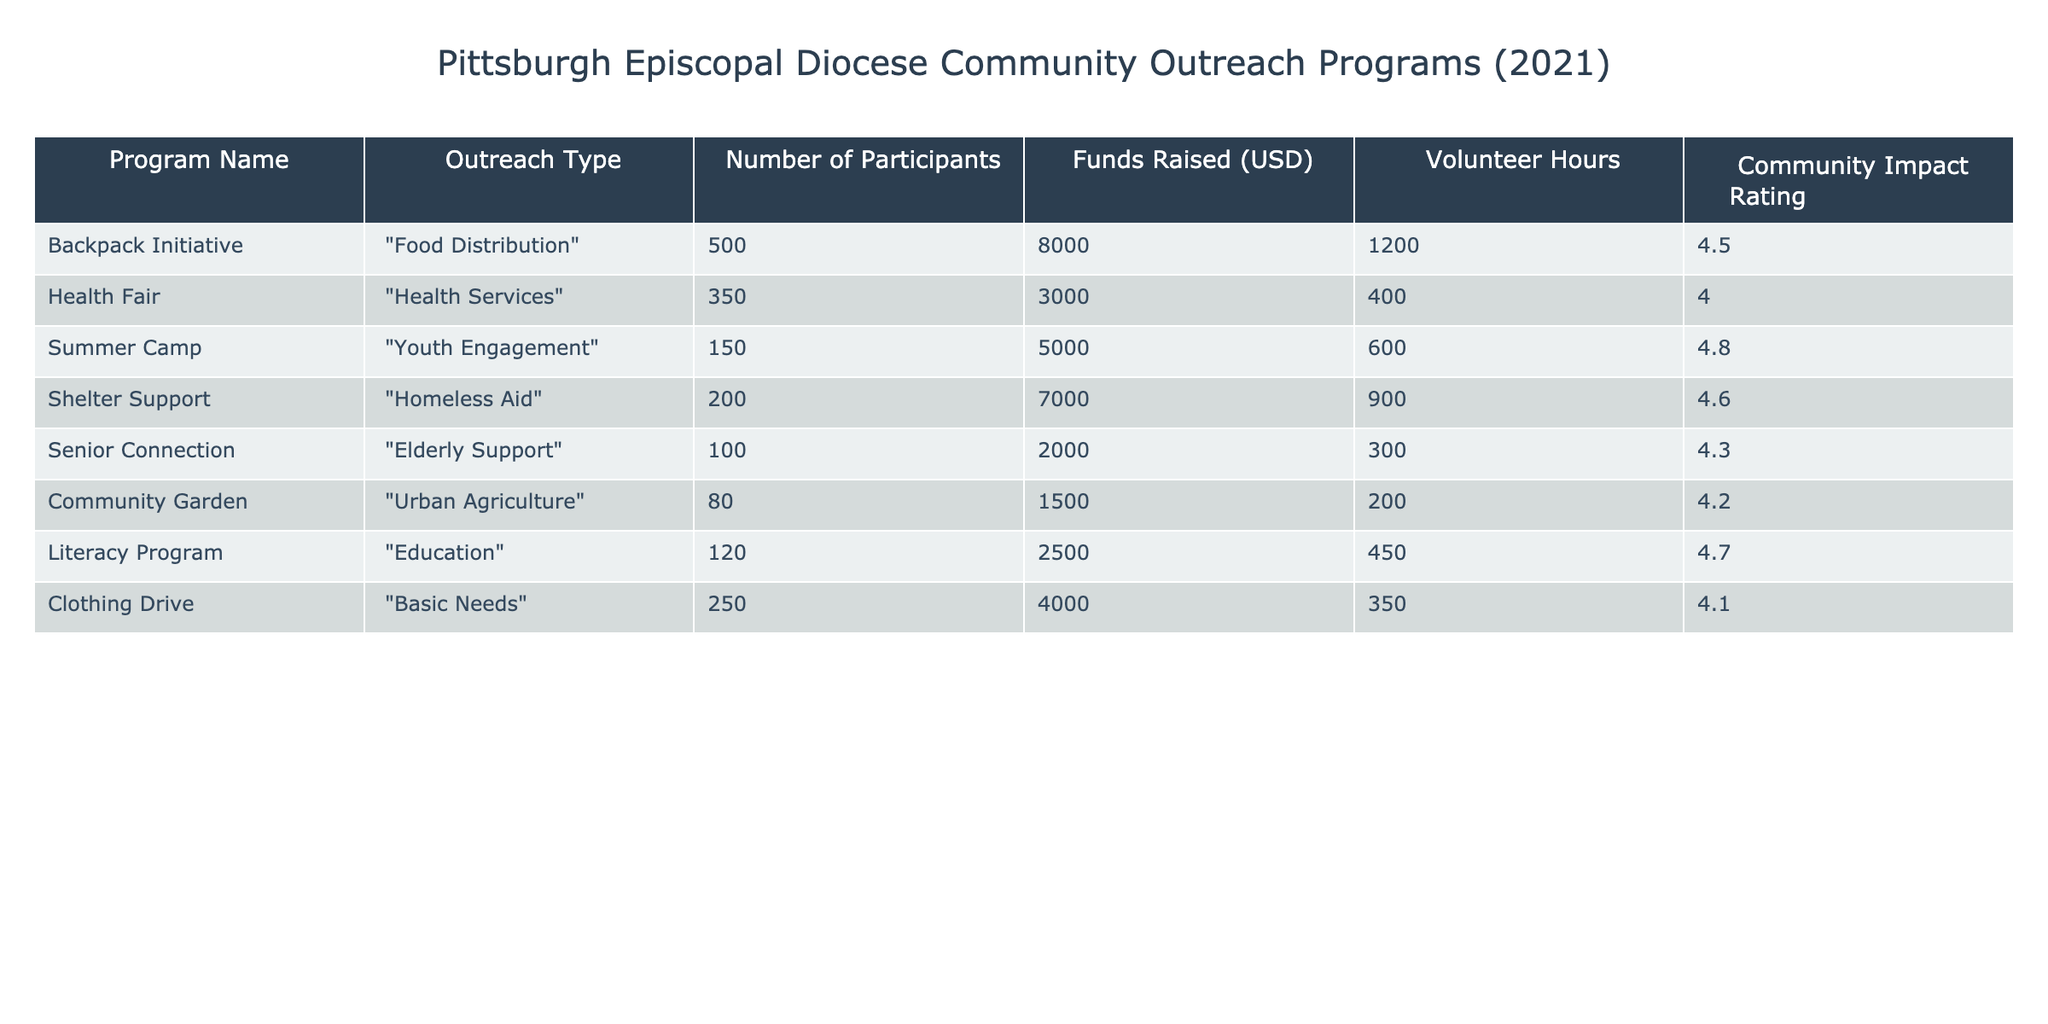What is the program with the highest community impact rating? Looking through the "Community Impact Rating" column, we see the "Summer Camp" program has a rating of 4.8, which is the highest compared to other programs.
Answer: Summer Camp How many participants were involved in the "Literacy Program"? In the table, we can find the "Literacy Program," which has "Number of Participants" listed as 120.
Answer: 120 What is the total amount of funds raised from all programs? To find the total funds raised, we sum the "Funds Raised (USD)" for each program: 8000 + 3000 + 5000 + 7000 + 2000 + 1500 + 2500 + 4000 = 28500.
Answer: 28500 Is the outreach program "Community Garden" focused on health services? The "Community Garden" is categorized under "Urban Agriculture," not health services, so the statement is false.
Answer: No What is the average number of volunteer hours across all programs? To calculate the average volunteer hours, we first sum the "Volunteer Hours": 1200 + 400 + 600 + 900 + 300 + 200 + 450 + 350 = 4100. There are 8 programs, so the average is 4100 / 8 = 512.5.
Answer: 512.5 Which outreach type had the least number of participants? By examining the "Outreach Type" along with the "Number of Participants," we see "Community Garden" with 80 participants is the lowest.
Answer: Urban Agriculture Did the "Health Fair" raise more funds than the "Shelter Support"? The "Health Fair" raised 3000 while the "Shelter Support" raised 7000; since 3000 is less than 7000, the statement is false.
Answer: No How does the community impact rating of the "Clothing Drive" compare to the "Backpack Initiative"? The "Clothing Drive" has a rating of 4.1, while the "Backpack Initiative" has 4.5. Since 4.1 is less than 4.5, we can conclude that the "Clothing Drive" has a lower impact rating.
Answer: Lower What percentage of the total volunteer hours did the "Senior Connection" contribute? The total volunteer hours are 4100. The "Senior Connection" contributed 300 hours. To find the percentage, we calculate (300 / 4100) * 100 = 7.32%.
Answer: 7.32% 